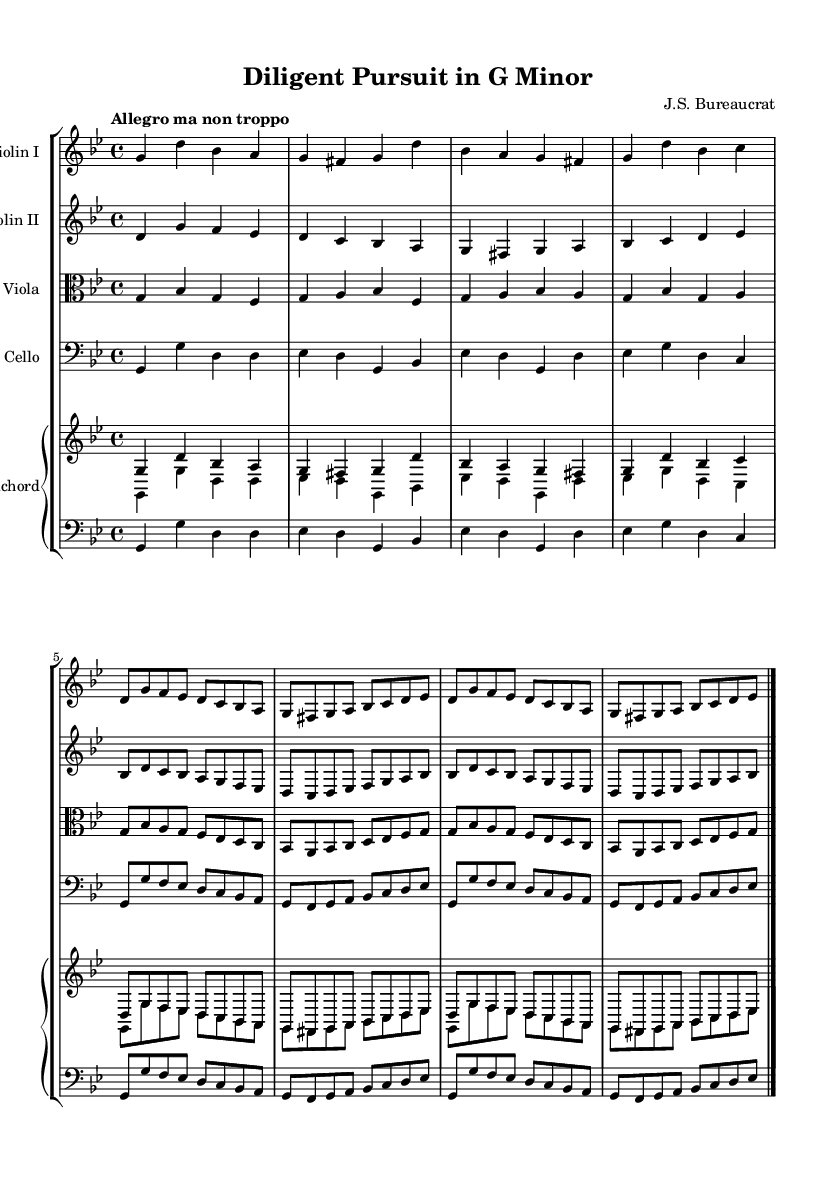What is the key signature of this music? The key signature is indicated by the sharp or flat signs at the beginning of the staff. In this score, there are two flats, which corresponds to the key of G minor.
Answer: G minor What is the time signature of this music? The time signature is located right after the key signature at the beginning of the score. Here, it shows the numbers 4 and 4, indicating a common time of four beats per measure.
Answer: 4/4 What is the tempo marking of this music? The tempo marking is typically noted above the staff, and in this case, it reads "Allegro ma non troppo," indicating a lively but not excessively fast pace.
Answer: Allegro ma non troppo How many measures are repeated in the violin parts? The score contains a repeat sign after two measures in the violin parts, which indicates that these two measures should be played twice. Counting these, there are two measures repeated in each violin part.
Answer: 2 What is the primary texture of this piece? Baroque music often features counterpoint and harmony played by multiple instruments, and in this score, we see the interplay of different strings and harpsichord, indicating a polyphonic texture.
Answer: Polyphonic What instrument plays the bass line in this score? The bass line is provided in the score, and the instrument responsible for this part is the cello, which is positioned in the bass clef indicating its role as the lowest string instrument.
Answer: Cello What is the role of the harpsichord in this composition? The harpsichord in Baroque music typically provides both harmony and rhythmic support, playing chords and support to the upper string melodies, which can be seen in the intertwined staffs in the score.
Answer: Harmony 